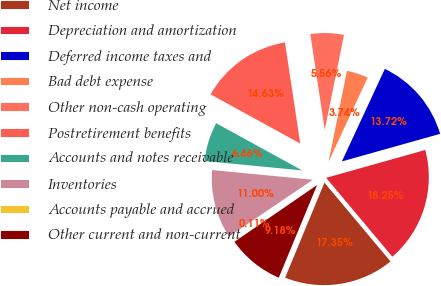<chart> <loc_0><loc_0><loc_500><loc_500><pie_chart><fcel>Net income<fcel>Depreciation and amortization<fcel>Deferred income taxes and<fcel>Bad debt expense<fcel>Other non-cash operating<fcel>Postretirement benefits<fcel>Accounts and notes receivable<fcel>Inventories<fcel>Accounts payable and accrued<fcel>Other current and non-current<nl><fcel>17.35%<fcel>18.25%<fcel>13.72%<fcel>3.74%<fcel>5.56%<fcel>14.63%<fcel>6.46%<fcel>11.0%<fcel>0.11%<fcel>9.18%<nl></chart> 